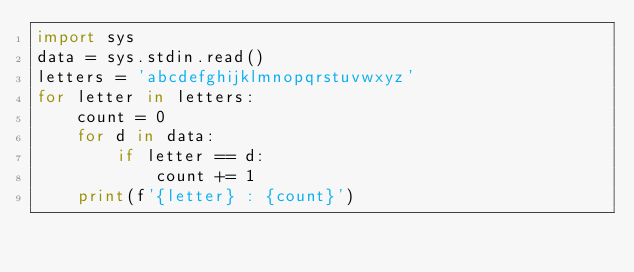Convert code to text. <code><loc_0><loc_0><loc_500><loc_500><_Python_>import sys
data = sys.stdin.read()
letters = 'abcdefghijklmnopqrstuvwxyz'
for letter in letters:
    count = 0
    for d in data:
        if letter == d:
            count += 1
    print(f'{letter} : {count}')

</code> 